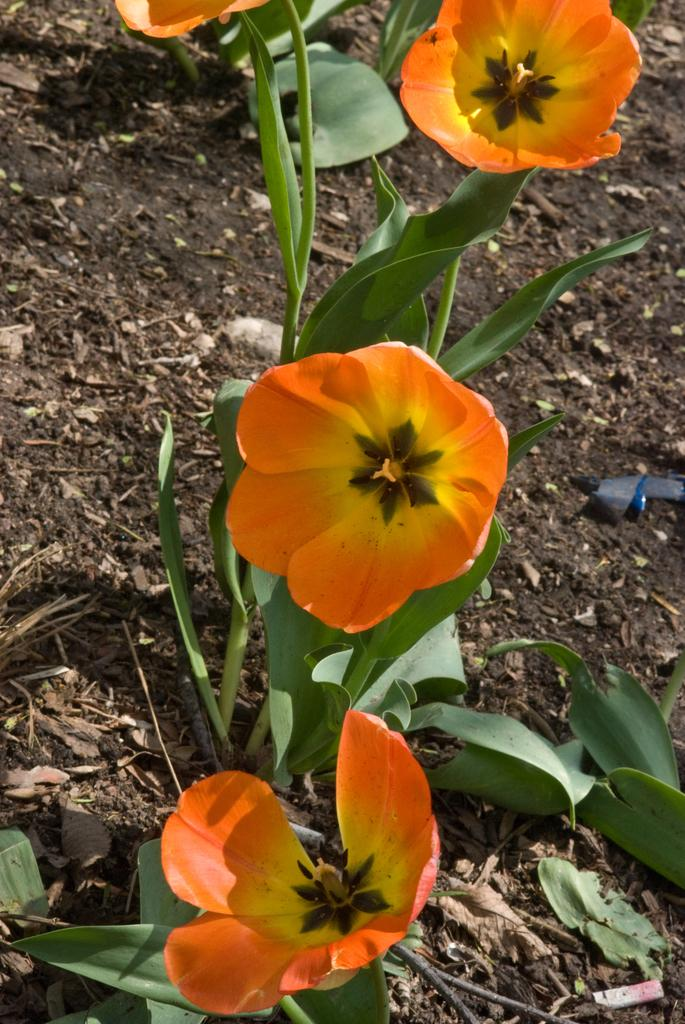What type of plants can be seen in the image? There are flowers in the image. What colors are the flowers? The flowers are in yellow and orange colors. What else is present in the image besides the flowers? There are leaves in the image. What color are the leaves? The leaves are green in color. What time of day is it in the image, given the presence of morning dew on the flowers? There is no mention of dew or any specific time of day in the image, so it cannot be determined from the image alone. 